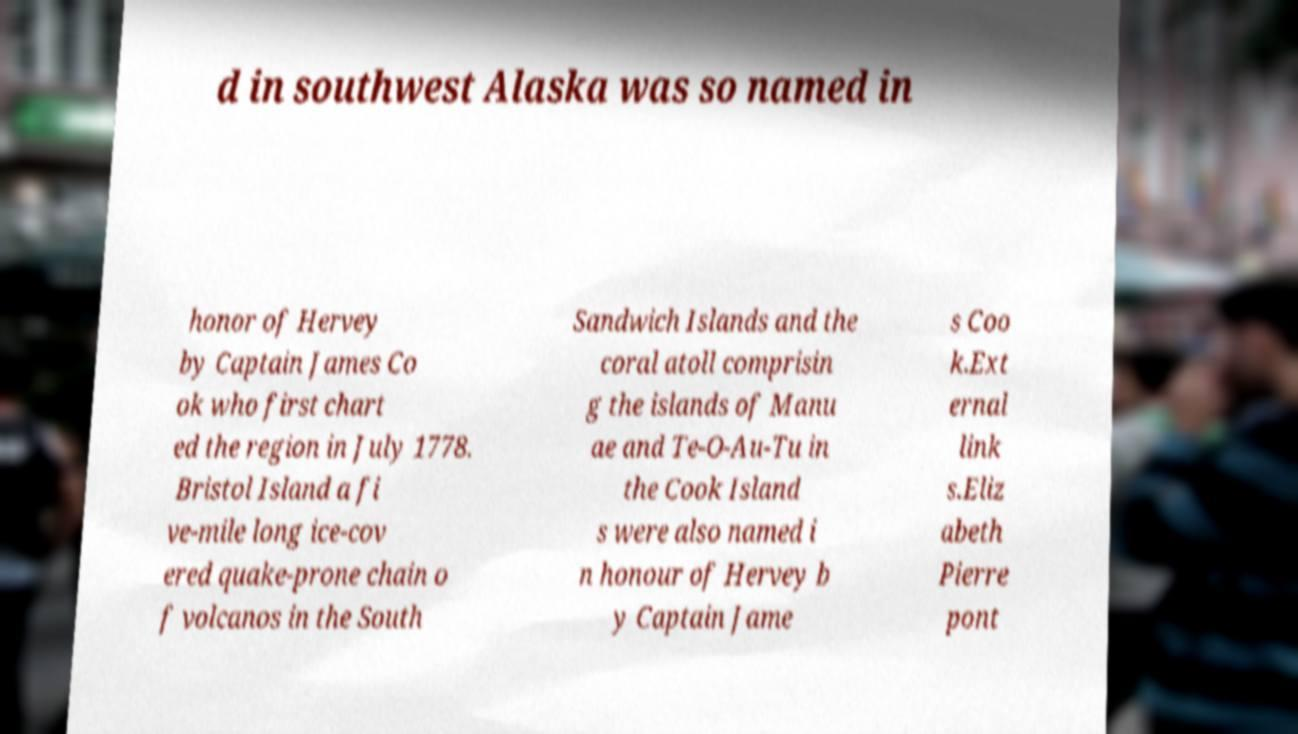I need the written content from this picture converted into text. Can you do that? d in southwest Alaska was so named in honor of Hervey by Captain James Co ok who first chart ed the region in July 1778. Bristol Island a fi ve-mile long ice-cov ered quake-prone chain o f volcanos in the South Sandwich Islands and the coral atoll comprisin g the islands of Manu ae and Te-O-Au-Tu in the Cook Island s were also named i n honour of Hervey b y Captain Jame s Coo k.Ext ernal link s.Eliz abeth Pierre pont 